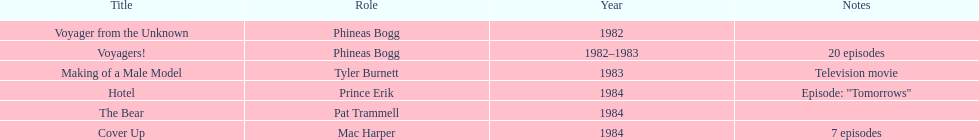Which year did he play the role of mac harper and also pat trammell? 1984. 